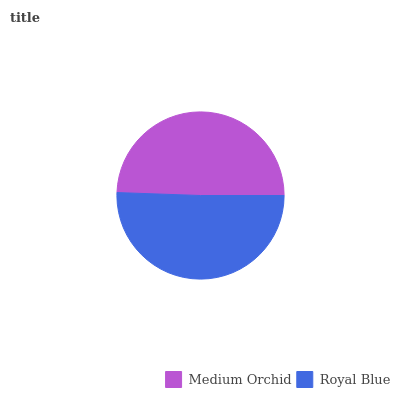Is Medium Orchid the minimum?
Answer yes or no. Yes. Is Royal Blue the maximum?
Answer yes or no. Yes. Is Royal Blue the minimum?
Answer yes or no. No. Is Royal Blue greater than Medium Orchid?
Answer yes or no. Yes. Is Medium Orchid less than Royal Blue?
Answer yes or no. Yes. Is Medium Orchid greater than Royal Blue?
Answer yes or no. No. Is Royal Blue less than Medium Orchid?
Answer yes or no. No. Is Royal Blue the high median?
Answer yes or no. Yes. Is Medium Orchid the low median?
Answer yes or no. Yes. Is Medium Orchid the high median?
Answer yes or no. No. Is Royal Blue the low median?
Answer yes or no. No. 